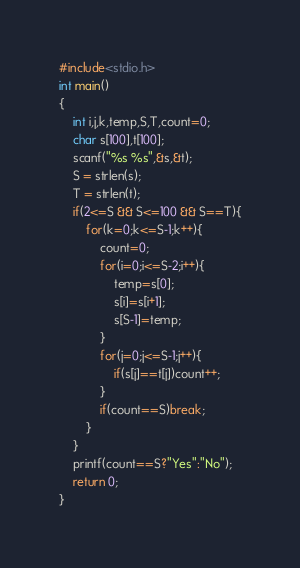<code> <loc_0><loc_0><loc_500><loc_500><_C_>#include<stdio.h>
int main()
{
	int i,j,k,temp,S,T,count=0;
	char s[100],t[100];
	scanf("%s %s",&s,&t);
	S = strlen(s);
	T = strlen(t);
	if(2<=S && S<=100 && S==T){
		for(k=0;k<=S-1;k++){
			count=0;
			for(i=0;i<=S-2;i++){
				temp=s[0];
				s[i]=s[i+1];
				s[S-1]=temp;
			}
			for(j=0;j<=S-1;j++){
				if(s[j]==t[j])count++;
			}
			if(count==S)break;
		}
	}
	printf(count==S?"Yes":"No");
	return 0;
}</code> 